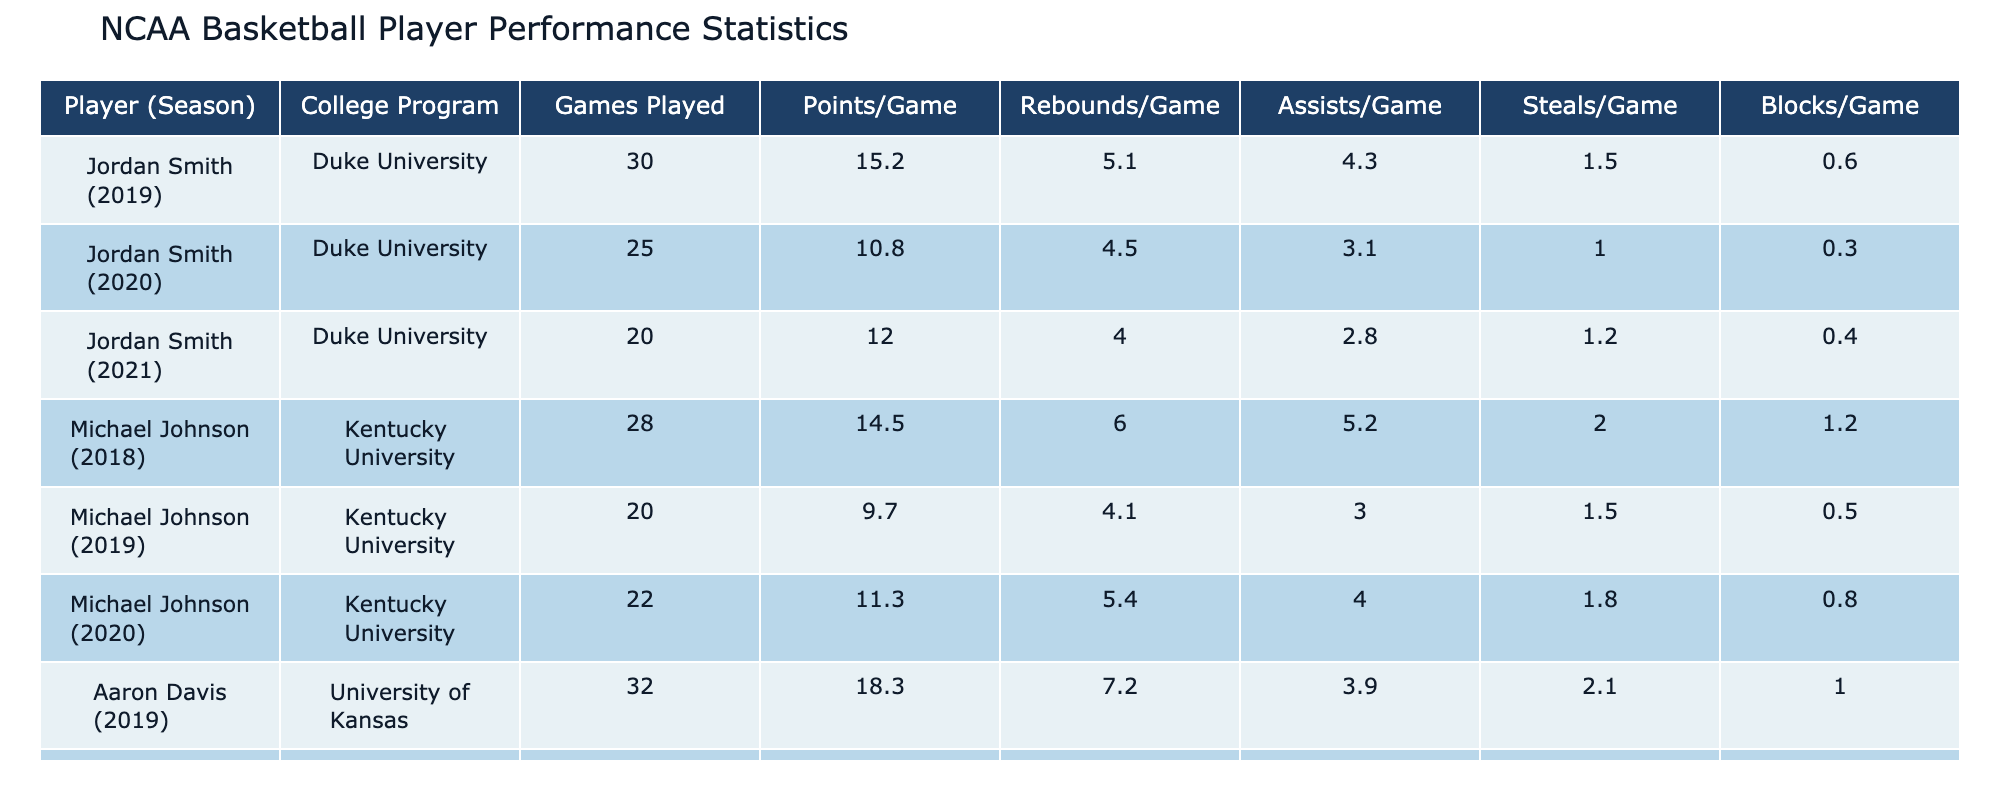What was Jordan Smith's points per game in the 2020 season? According to the table, the entry for Jordan Smith for the 2020 season shows his points per game as 10.8.
Answer: 10.8 How many games did Aaron Davis play in the 2019 season? The table displays that Aaron Davis played 32 games during the 2019 season.
Answer: 32 What is the difference in rebounds per game for Michael Johnson from the 2018 season to the 2020 season? In the 2018 season, Michael Johnson had an average of 6.0 rebounds per game, while in the 2020 season, he had 4.0 rebounds per game. The difference is 6.0 - 4.0 = 2.0.
Answer: 2.0 Did Jordan Smith improve his steals per game from the 2020 season to the 2021 season? In the 2020 season, Jordan Smith averaged 1.0 steals per game, whereas in the 2021 season he averaged 1.2 steals per game, which indicates an improvement.
Answer: Yes What was the average points per game for Aaron Davis across the three seasons listed? To find the average, add his points per game for each season: 18.3 (2019) + 14.0 (2020) + 13.2 (2021) = 45.5. Then, divide by 3 seasons: 45.5 / 3 ≈ 15.17.
Answer: 15.17 What college program had a player with the highest average points per game in a single season? Aaron Davis from the University of Kansas had the highest average points per game at 18.3 during the 2019 season.
Answer: University of Kansas How many total games did Michael Johnson play across all seasons listed? Michael Johnson played 28 games in 2018, 20 in 2019, and 22 in 2020. Adding these gives 28 + 20 + 22 = 70 total games played.
Answer: 70 Did any player have a consistent increase in points per game across all their seasons? By analyzing the data, it can be seen that neither player had a consistent increase in points per game across all seasons; Jordan Smith's points varied, and Michael Johnson also fluctuated.
Answer: No 